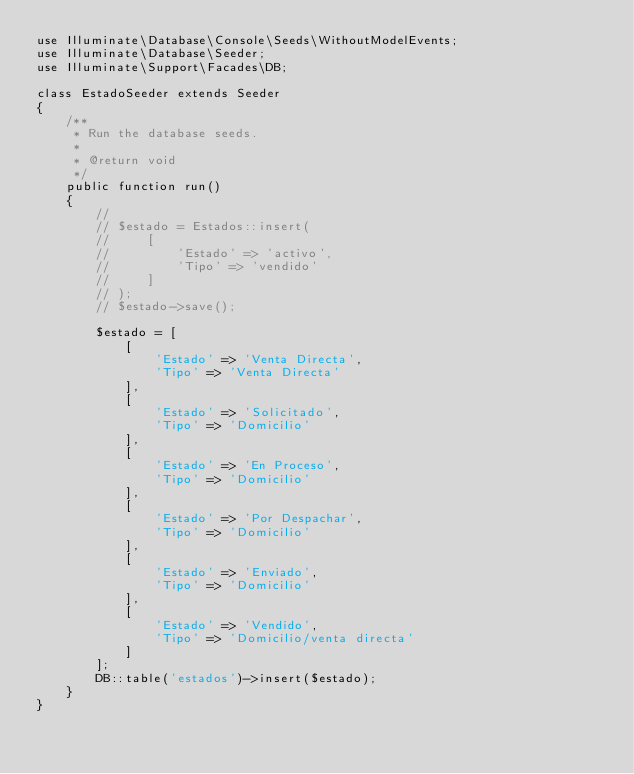<code> <loc_0><loc_0><loc_500><loc_500><_PHP_>use Illuminate\Database\Console\Seeds\WithoutModelEvents;
use Illuminate\Database\Seeder;
use Illuminate\Support\Facades\DB;

class EstadoSeeder extends Seeder
{
    /**
     * Run the database seeds.
     *
     * @return void
     */
    public function run()
    {
        //
        // $estado = Estados::insert(
        //     [
        //         'Estado' => 'activo',
        //         'Tipo' => 'vendido'
        //     ]
        // );
        // $estado->save();

        $estado = [
            [
                'Estado' => 'Venta Directa',
                'Tipo' => 'Venta Directa'
            ],
            [
                'Estado' => 'Solicitado',
                'Tipo' => 'Domicilio'
            ],
            [
                'Estado' => 'En Proceso',
                'Tipo' => 'Domicilio'
            ],
            [
                'Estado' => 'Por Despachar',
                'Tipo' => 'Domicilio'
            ],
            [
                'Estado' => 'Enviado',
                'Tipo' => 'Domicilio'
            ],
            [
                'Estado' => 'Vendido',
                'Tipo' => 'Domicilio/venta directa'
            ]
        ];
        DB::table('estados')->insert($estado);
    }
}
</code> 